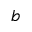<formula> <loc_0><loc_0><loc_500><loc_500>b</formula> 